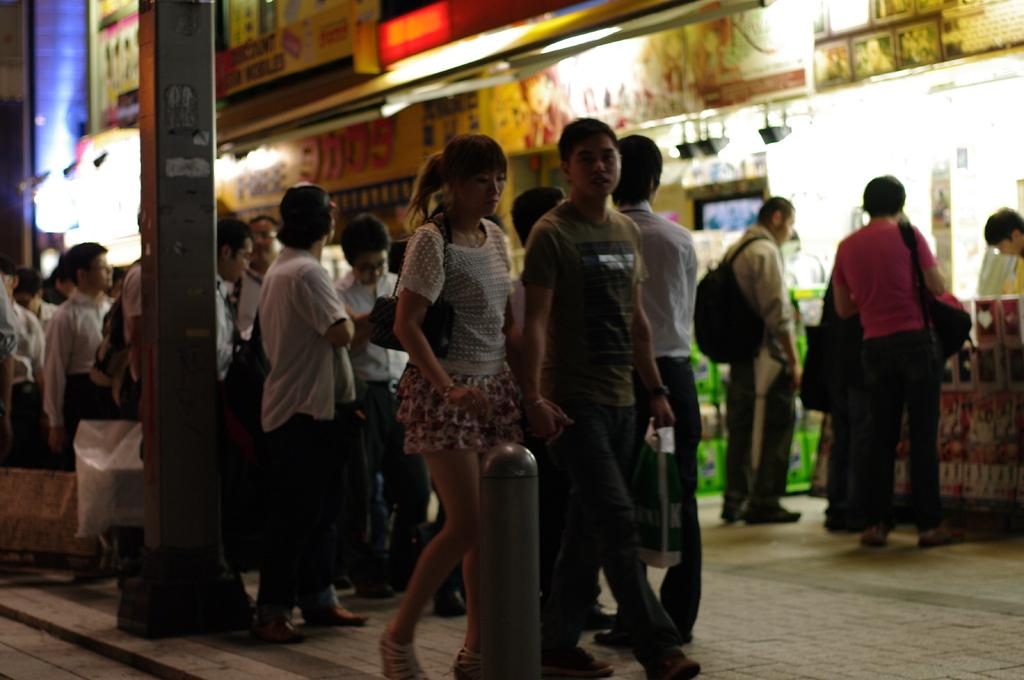What are the two people in the image doing? The two people in the image are walking. What is happening with the group of people in the image? The group of people is standing on a pathway. What can be seen in the image besides the people? There is a pole in the image, and shops are visible in the background. What features are present on the shops? Name boards and lights are present on the shops. Can you tell me how many toes are visible on the people in the image? There is no information about the toes of the people in the image, as the focus is on their walking and standing positions. --- Facts: 1. There is a car in the image. 2. The car is parked on the side of the road. 3. There is a tree next to the car. 4. The car has a flat tire. 5. There is a person standing next to the car. Absurd Topics: ocean, parrot, dance Conversation: What is the main subject of the image? The main subject of the image is a car. Where is the car located in the image? The car is parked on the side of the road. What can be seen next to the car in the image? There is a tree next to the car. What is the condition of the car in the image? The car has a flat tire. Is there anyone near the car in the image? Yes, there is a person standing next to the car. Reasoning: Let's think step by step in order to produce the conversation. We start by identifying the main subject in the image, which is the car. Then, we expand the conversation to include other details about the image, such as the car's location, the presence of a tree, the condition of the car, and the presence of a person. Each question is designed to elicit a specific detail about the image that is known from the provided facts. Absurd Question/Answer: Can you tell me how many parrots are sitting on the car in the image? There are no parrots present in the image; the focus is on the car, its location, and the person standing next to it. 